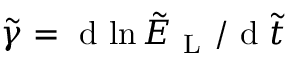<formula> <loc_0><loc_0><loc_500><loc_500>\tilde { \gamma } = d { \ln \tilde { E } _ { L } } / d \tilde { t }</formula> 